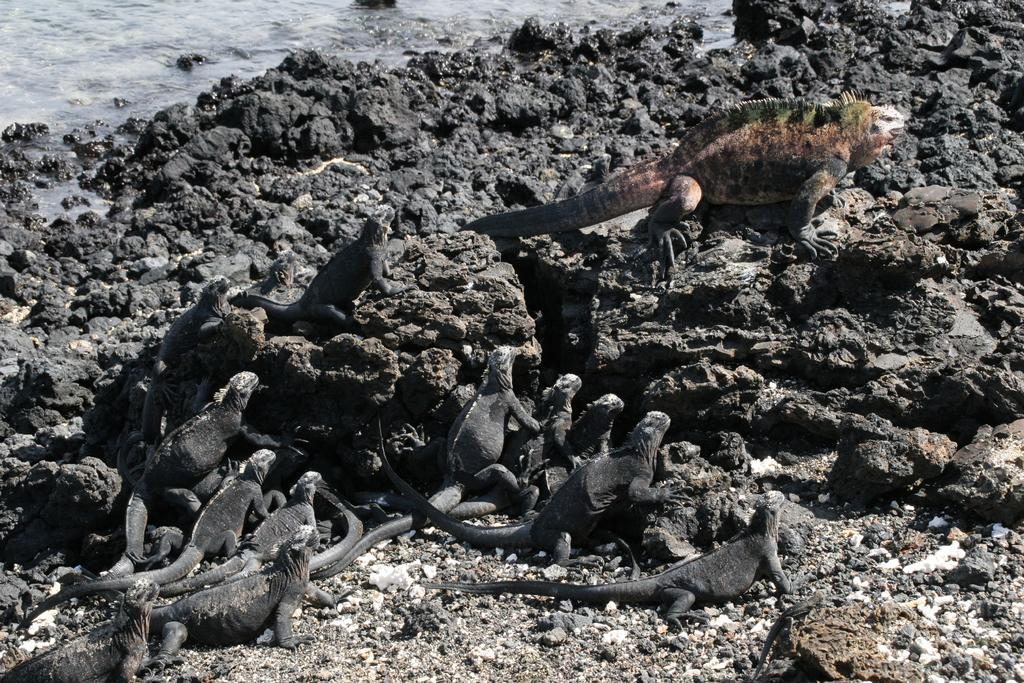What type of animals are in the center of the image? There are reptiles in the center of the image. What can be seen in the background of the image? There is water and mud visible in the background of the image. How many drawers are visible in the image? There are no drawers present in the image. What type of stitch is used to create the reptiles in the image? The reptiles in the image are not created using stitching; they are real animals. 